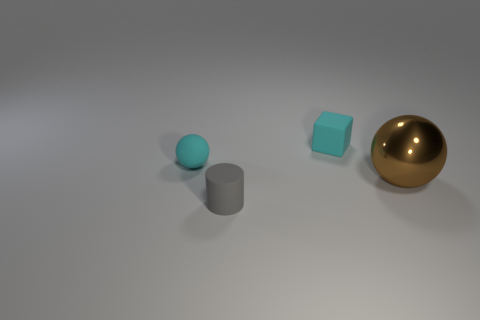What concepts could this arrangement of shapes represent? This arrangement of shapes might represent a study in contrast and diversity, symbolizing how different forms and materials can coexist harmoniously. It could also signify progression or evolution, as the objects increase in size from left to right. Another idea could be balance, as despite the differences in shapes and sizes, the objects are placed in a way that feels stable and aesthetically pleasing. 